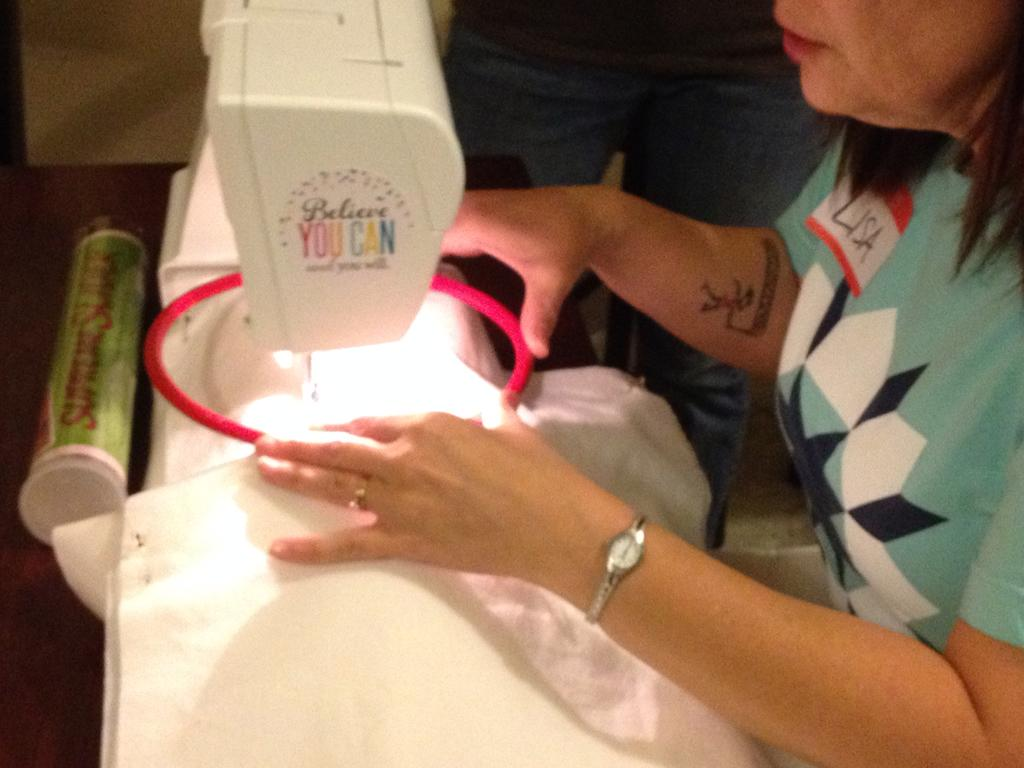Who is the main subject in the image? There is a woman in the image. What is the woman doing in the image? The woman is stitching cloth in the image. What tool is the woman using for stitching? The woman is using a machine for stitching in the image. Is there anyone else present in the image? Yes, there is a person standing beside the woman in the image. What type of deer can be seen in the image? There is no deer present in the image. What is the spark produced by the stitching machine in the image? The stitching machine in the image does not produce a spark; it is used for stitching cloth. 